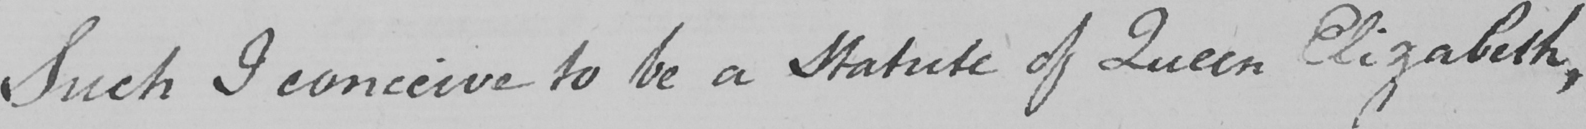What does this handwritten line say? Such I conceive to be a Statute of Queen Elizabeth , 